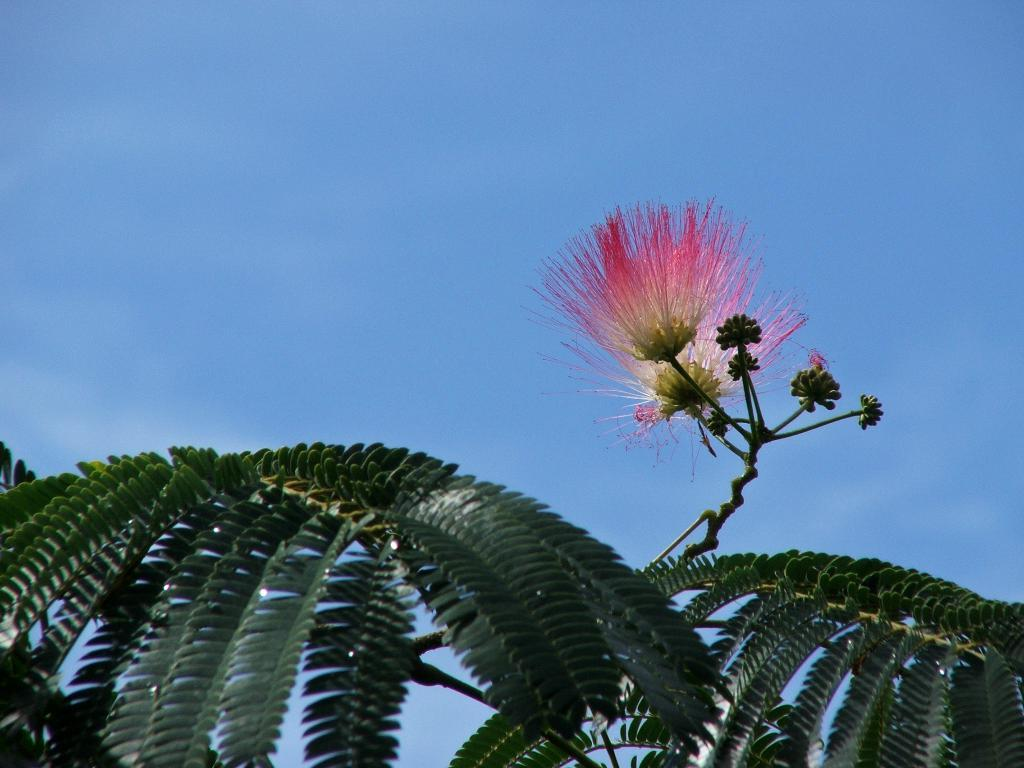What type of plants can be seen in the image? There are flowers and leaves in the image. Where are the flowers and leaves located in the image? The flowers and leaves are at the bottom side of the image. What is visible above the flowers and leaves in the image? The sky is visible in the image. Where is the sky located in the image? The sky is at the top side of the image. What type of curve can be seen in the image? There is no curve present in the image; it features flowers, leaves, and sky. Can you see your aunt in the image? There is no person, including an aunt, present in the image. 